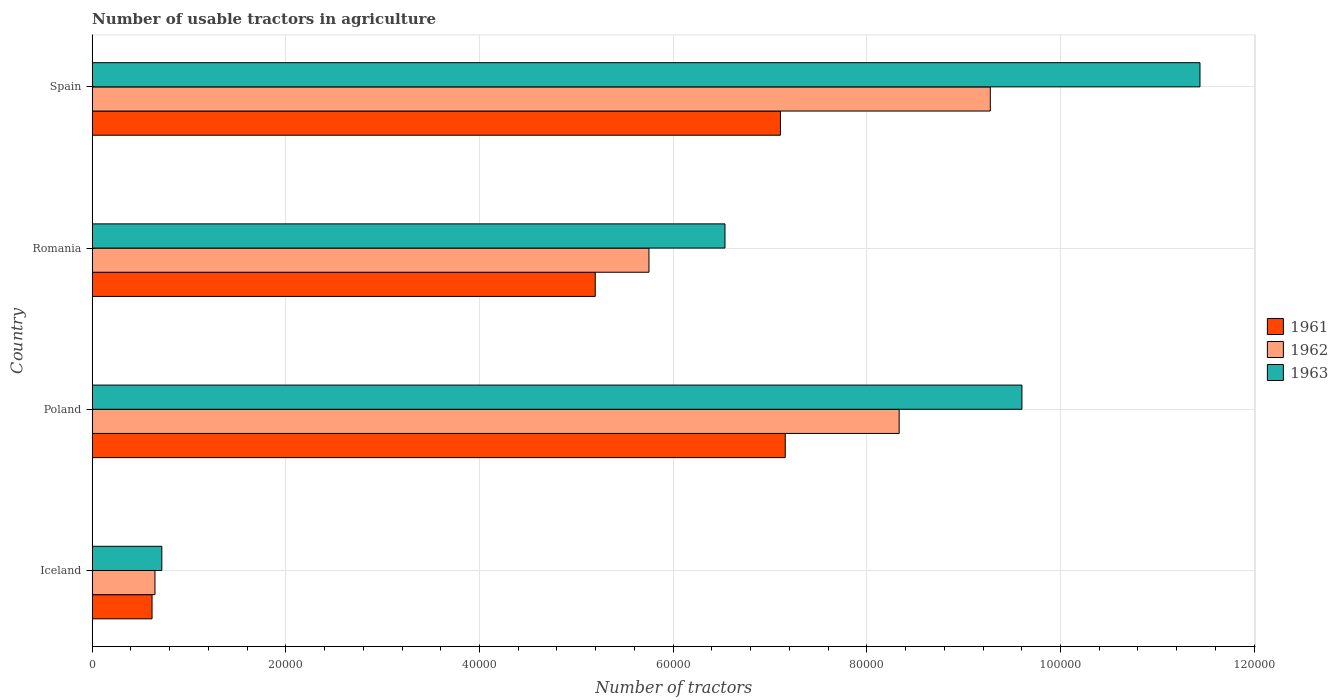How many different coloured bars are there?
Your response must be concise. 3. Are the number of bars per tick equal to the number of legend labels?
Offer a very short reply. Yes. Are the number of bars on each tick of the Y-axis equal?
Offer a very short reply. Yes. How many bars are there on the 3rd tick from the top?
Your answer should be very brief. 3. What is the label of the 2nd group of bars from the top?
Offer a terse response. Romania. What is the number of usable tractors in agriculture in 1962 in Poland?
Your answer should be very brief. 8.33e+04. Across all countries, what is the maximum number of usable tractors in agriculture in 1963?
Your answer should be very brief. 1.14e+05. Across all countries, what is the minimum number of usable tractors in agriculture in 1962?
Make the answer very short. 6479. In which country was the number of usable tractors in agriculture in 1963 maximum?
Make the answer very short. Spain. What is the total number of usable tractors in agriculture in 1963 in the graph?
Your answer should be compact. 2.83e+05. What is the difference between the number of usable tractors in agriculture in 1963 in Poland and that in Spain?
Keep it short and to the point. -1.84e+04. What is the difference between the number of usable tractors in agriculture in 1962 in Romania and the number of usable tractors in agriculture in 1963 in Spain?
Your answer should be compact. -5.69e+04. What is the average number of usable tractors in agriculture in 1962 per country?
Keep it short and to the point. 6.00e+04. What is the difference between the number of usable tractors in agriculture in 1963 and number of usable tractors in agriculture in 1961 in Iceland?
Your answer should be very brief. 1010. What is the ratio of the number of usable tractors in agriculture in 1963 in Poland to that in Spain?
Ensure brevity in your answer.  0.84. What is the difference between the highest and the second highest number of usable tractors in agriculture in 1963?
Provide a short and direct response. 1.84e+04. What is the difference between the highest and the lowest number of usable tractors in agriculture in 1961?
Offer a very short reply. 6.54e+04. In how many countries, is the number of usable tractors in agriculture in 1961 greater than the average number of usable tractors in agriculture in 1961 taken over all countries?
Make the answer very short. 3. Is the sum of the number of usable tractors in agriculture in 1961 in Poland and Spain greater than the maximum number of usable tractors in agriculture in 1962 across all countries?
Provide a succinct answer. Yes. What does the 1st bar from the bottom in Iceland represents?
Keep it short and to the point. 1961. Are all the bars in the graph horizontal?
Offer a terse response. Yes. Does the graph contain any zero values?
Your response must be concise. No. Where does the legend appear in the graph?
Ensure brevity in your answer.  Center right. How many legend labels are there?
Keep it short and to the point. 3. What is the title of the graph?
Offer a terse response. Number of usable tractors in agriculture. Does "1961" appear as one of the legend labels in the graph?
Your answer should be compact. Yes. What is the label or title of the X-axis?
Keep it short and to the point. Number of tractors. What is the Number of tractors in 1961 in Iceland?
Offer a very short reply. 6177. What is the Number of tractors in 1962 in Iceland?
Keep it short and to the point. 6479. What is the Number of tractors of 1963 in Iceland?
Make the answer very short. 7187. What is the Number of tractors of 1961 in Poland?
Provide a succinct answer. 7.16e+04. What is the Number of tractors of 1962 in Poland?
Your answer should be compact. 8.33e+04. What is the Number of tractors in 1963 in Poland?
Offer a terse response. 9.60e+04. What is the Number of tractors of 1961 in Romania?
Give a very brief answer. 5.20e+04. What is the Number of tractors of 1962 in Romania?
Your answer should be very brief. 5.75e+04. What is the Number of tractors in 1963 in Romania?
Give a very brief answer. 6.54e+04. What is the Number of tractors in 1961 in Spain?
Make the answer very short. 7.11e+04. What is the Number of tractors in 1962 in Spain?
Provide a short and direct response. 9.28e+04. What is the Number of tractors in 1963 in Spain?
Your answer should be very brief. 1.14e+05. Across all countries, what is the maximum Number of tractors of 1961?
Your answer should be compact. 7.16e+04. Across all countries, what is the maximum Number of tractors in 1962?
Your answer should be very brief. 9.28e+04. Across all countries, what is the maximum Number of tractors of 1963?
Your answer should be compact. 1.14e+05. Across all countries, what is the minimum Number of tractors in 1961?
Provide a short and direct response. 6177. Across all countries, what is the minimum Number of tractors of 1962?
Give a very brief answer. 6479. Across all countries, what is the minimum Number of tractors in 1963?
Provide a succinct answer. 7187. What is the total Number of tractors in 1961 in the graph?
Make the answer very short. 2.01e+05. What is the total Number of tractors in 1962 in the graph?
Keep it short and to the point. 2.40e+05. What is the total Number of tractors of 1963 in the graph?
Ensure brevity in your answer.  2.83e+05. What is the difference between the Number of tractors in 1961 in Iceland and that in Poland?
Keep it short and to the point. -6.54e+04. What is the difference between the Number of tractors of 1962 in Iceland and that in Poland?
Provide a short and direct response. -7.69e+04. What is the difference between the Number of tractors of 1963 in Iceland and that in Poland?
Provide a succinct answer. -8.88e+04. What is the difference between the Number of tractors of 1961 in Iceland and that in Romania?
Provide a succinct answer. -4.58e+04. What is the difference between the Number of tractors in 1962 in Iceland and that in Romania?
Provide a short and direct response. -5.10e+04. What is the difference between the Number of tractors of 1963 in Iceland and that in Romania?
Make the answer very short. -5.82e+04. What is the difference between the Number of tractors in 1961 in Iceland and that in Spain?
Make the answer very short. -6.49e+04. What is the difference between the Number of tractors in 1962 in Iceland and that in Spain?
Give a very brief answer. -8.63e+04. What is the difference between the Number of tractors in 1963 in Iceland and that in Spain?
Ensure brevity in your answer.  -1.07e+05. What is the difference between the Number of tractors in 1961 in Poland and that in Romania?
Give a very brief answer. 1.96e+04. What is the difference between the Number of tractors in 1962 in Poland and that in Romania?
Your response must be concise. 2.58e+04. What is the difference between the Number of tractors of 1963 in Poland and that in Romania?
Give a very brief answer. 3.07e+04. What is the difference between the Number of tractors of 1962 in Poland and that in Spain?
Make the answer very short. -9414. What is the difference between the Number of tractors in 1963 in Poland and that in Spain?
Your answer should be compact. -1.84e+04. What is the difference between the Number of tractors in 1961 in Romania and that in Spain?
Your answer should be very brief. -1.91e+04. What is the difference between the Number of tractors in 1962 in Romania and that in Spain?
Provide a short and direct response. -3.53e+04. What is the difference between the Number of tractors in 1963 in Romania and that in Spain?
Your response must be concise. -4.91e+04. What is the difference between the Number of tractors of 1961 in Iceland and the Number of tractors of 1962 in Poland?
Your response must be concise. -7.72e+04. What is the difference between the Number of tractors of 1961 in Iceland and the Number of tractors of 1963 in Poland?
Your response must be concise. -8.98e+04. What is the difference between the Number of tractors in 1962 in Iceland and the Number of tractors in 1963 in Poland?
Ensure brevity in your answer.  -8.95e+04. What is the difference between the Number of tractors of 1961 in Iceland and the Number of tractors of 1962 in Romania?
Your response must be concise. -5.13e+04. What is the difference between the Number of tractors of 1961 in Iceland and the Number of tractors of 1963 in Romania?
Your answer should be very brief. -5.92e+04. What is the difference between the Number of tractors of 1962 in Iceland and the Number of tractors of 1963 in Romania?
Your answer should be compact. -5.89e+04. What is the difference between the Number of tractors in 1961 in Iceland and the Number of tractors in 1962 in Spain?
Ensure brevity in your answer.  -8.66e+04. What is the difference between the Number of tractors of 1961 in Iceland and the Number of tractors of 1963 in Spain?
Make the answer very short. -1.08e+05. What is the difference between the Number of tractors in 1962 in Iceland and the Number of tractors in 1963 in Spain?
Provide a short and direct response. -1.08e+05. What is the difference between the Number of tractors of 1961 in Poland and the Number of tractors of 1962 in Romania?
Your response must be concise. 1.41e+04. What is the difference between the Number of tractors in 1961 in Poland and the Number of tractors in 1963 in Romania?
Your answer should be compact. 6226. What is the difference between the Number of tractors of 1962 in Poland and the Number of tractors of 1963 in Romania?
Your answer should be compact. 1.80e+04. What is the difference between the Number of tractors in 1961 in Poland and the Number of tractors in 1962 in Spain?
Provide a short and direct response. -2.12e+04. What is the difference between the Number of tractors in 1961 in Poland and the Number of tractors in 1963 in Spain?
Keep it short and to the point. -4.28e+04. What is the difference between the Number of tractors in 1962 in Poland and the Number of tractors in 1963 in Spain?
Your response must be concise. -3.11e+04. What is the difference between the Number of tractors in 1961 in Romania and the Number of tractors in 1962 in Spain?
Offer a terse response. -4.08e+04. What is the difference between the Number of tractors in 1961 in Romania and the Number of tractors in 1963 in Spain?
Your answer should be very brief. -6.25e+04. What is the difference between the Number of tractors of 1962 in Romania and the Number of tractors of 1963 in Spain?
Provide a short and direct response. -5.69e+04. What is the average Number of tractors of 1961 per country?
Keep it short and to the point. 5.02e+04. What is the average Number of tractors of 1962 per country?
Provide a short and direct response. 6.00e+04. What is the average Number of tractors in 1963 per country?
Your answer should be compact. 7.07e+04. What is the difference between the Number of tractors of 1961 and Number of tractors of 1962 in Iceland?
Keep it short and to the point. -302. What is the difference between the Number of tractors of 1961 and Number of tractors of 1963 in Iceland?
Your answer should be very brief. -1010. What is the difference between the Number of tractors in 1962 and Number of tractors in 1963 in Iceland?
Make the answer very short. -708. What is the difference between the Number of tractors in 1961 and Number of tractors in 1962 in Poland?
Give a very brief answer. -1.18e+04. What is the difference between the Number of tractors of 1961 and Number of tractors of 1963 in Poland?
Offer a very short reply. -2.44e+04. What is the difference between the Number of tractors in 1962 and Number of tractors in 1963 in Poland?
Keep it short and to the point. -1.27e+04. What is the difference between the Number of tractors in 1961 and Number of tractors in 1962 in Romania?
Make the answer very short. -5548. What is the difference between the Number of tractors in 1961 and Number of tractors in 1963 in Romania?
Make the answer very short. -1.34e+04. What is the difference between the Number of tractors in 1962 and Number of tractors in 1963 in Romania?
Provide a succinct answer. -7851. What is the difference between the Number of tractors in 1961 and Number of tractors in 1962 in Spain?
Make the answer very short. -2.17e+04. What is the difference between the Number of tractors of 1961 and Number of tractors of 1963 in Spain?
Your answer should be very brief. -4.33e+04. What is the difference between the Number of tractors in 1962 and Number of tractors in 1963 in Spain?
Make the answer very short. -2.17e+04. What is the ratio of the Number of tractors in 1961 in Iceland to that in Poland?
Give a very brief answer. 0.09. What is the ratio of the Number of tractors in 1962 in Iceland to that in Poland?
Give a very brief answer. 0.08. What is the ratio of the Number of tractors of 1963 in Iceland to that in Poland?
Your answer should be compact. 0.07. What is the ratio of the Number of tractors of 1961 in Iceland to that in Romania?
Your answer should be very brief. 0.12. What is the ratio of the Number of tractors of 1962 in Iceland to that in Romania?
Provide a succinct answer. 0.11. What is the ratio of the Number of tractors in 1963 in Iceland to that in Romania?
Your response must be concise. 0.11. What is the ratio of the Number of tractors of 1961 in Iceland to that in Spain?
Keep it short and to the point. 0.09. What is the ratio of the Number of tractors of 1962 in Iceland to that in Spain?
Provide a short and direct response. 0.07. What is the ratio of the Number of tractors of 1963 in Iceland to that in Spain?
Provide a succinct answer. 0.06. What is the ratio of the Number of tractors of 1961 in Poland to that in Romania?
Provide a succinct answer. 1.38. What is the ratio of the Number of tractors in 1962 in Poland to that in Romania?
Make the answer very short. 1.45. What is the ratio of the Number of tractors of 1963 in Poland to that in Romania?
Ensure brevity in your answer.  1.47. What is the ratio of the Number of tractors in 1961 in Poland to that in Spain?
Your answer should be very brief. 1.01. What is the ratio of the Number of tractors of 1962 in Poland to that in Spain?
Give a very brief answer. 0.9. What is the ratio of the Number of tractors of 1963 in Poland to that in Spain?
Provide a succinct answer. 0.84. What is the ratio of the Number of tractors of 1961 in Romania to that in Spain?
Keep it short and to the point. 0.73. What is the ratio of the Number of tractors in 1962 in Romania to that in Spain?
Give a very brief answer. 0.62. What is the ratio of the Number of tractors of 1963 in Romania to that in Spain?
Provide a succinct answer. 0.57. What is the difference between the highest and the second highest Number of tractors in 1961?
Ensure brevity in your answer.  500. What is the difference between the highest and the second highest Number of tractors of 1962?
Keep it short and to the point. 9414. What is the difference between the highest and the second highest Number of tractors of 1963?
Your answer should be very brief. 1.84e+04. What is the difference between the highest and the lowest Number of tractors of 1961?
Offer a very short reply. 6.54e+04. What is the difference between the highest and the lowest Number of tractors of 1962?
Offer a terse response. 8.63e+04. What is the difference between the highest and the lowest Number of tractors in 1963?
Offer a terse response. 1.07e+05. 